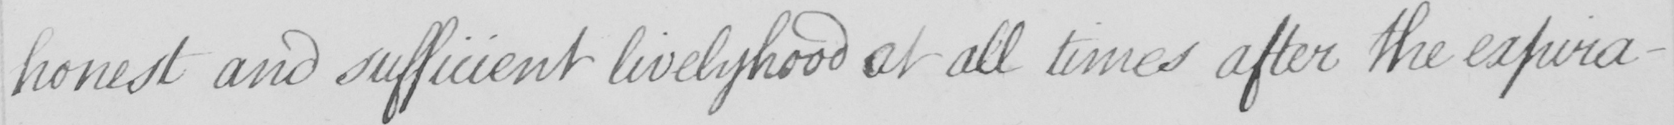Can you read and transcribe this handwriting? honest and sufficient livelyhood at all times after the expira- 